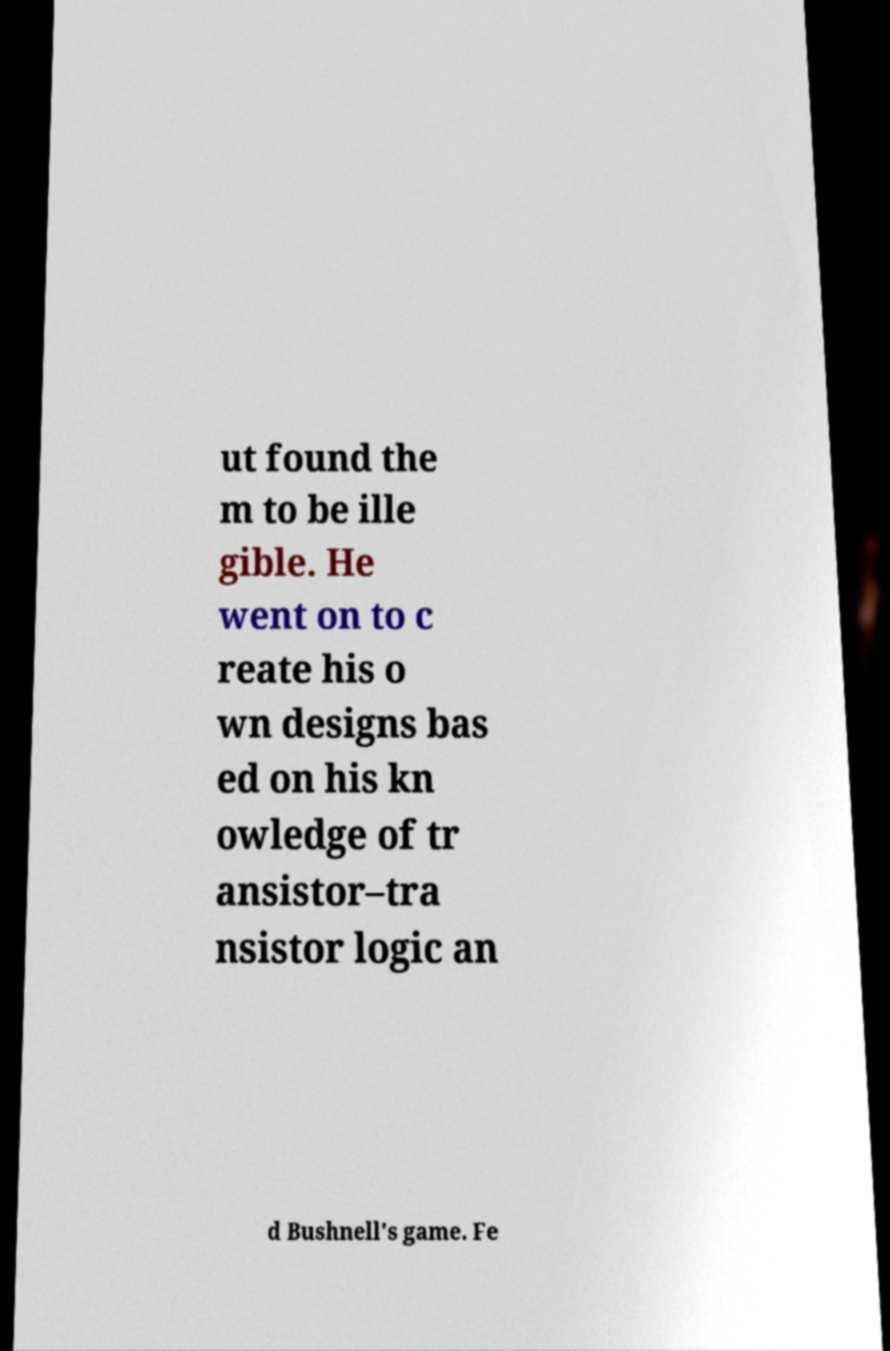Please identify and transcribe the text found in this image. ut found the m to be ille gible. He went on to c reate his o wn designs bas ed on his kn owledge of tr ansistor–tra nsistor logic an d Bushnell's game. Fe 